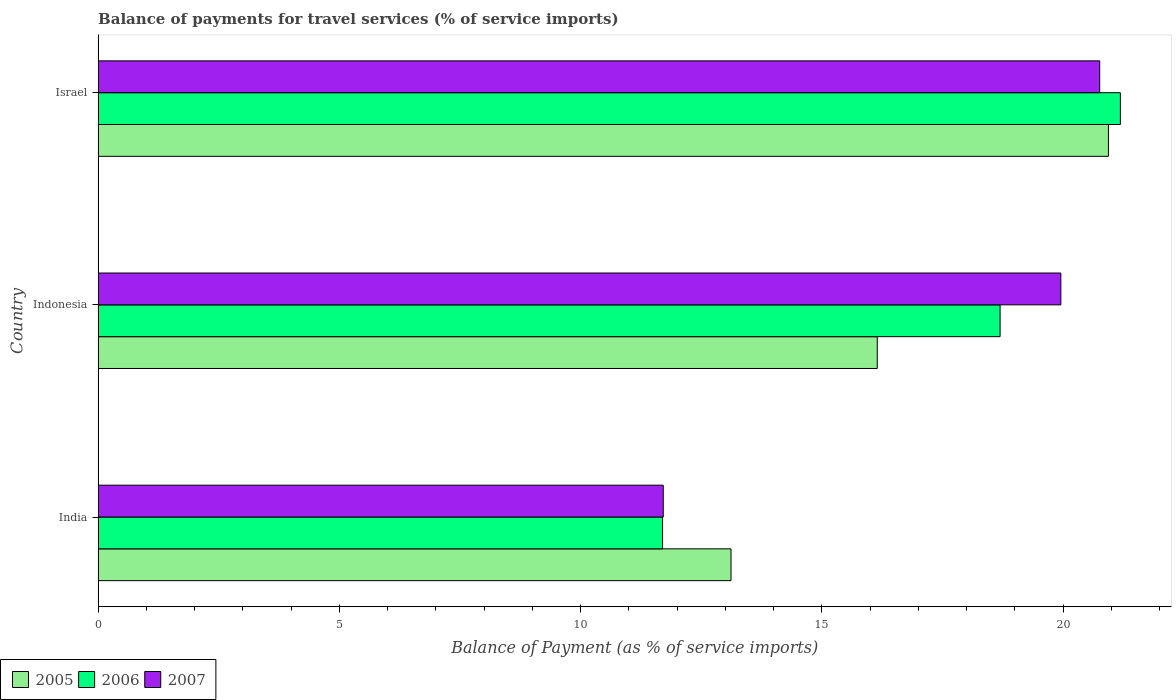How many different coloured bars are there?
Offer a terse response. 3. Are the number of bars per tick equal to the number of legend labels?
Offer a very short reply. Yes. How many bars are there on the 2nd tick from the bottom?
Give a very brief answer. 3. What is the balance of payments for travel services in 2006 in Israel?
Your answer should be compact. 21.19. Across all countries, what is the maximum balance of payments for travel services in 2006?
Your answer should be compact. 21.19. Across all countries, what is the minimum balance of payments for travel services in 2007?
Your answer should be compact. 11.71. What is the total balance of payments for travel services in 2006 in the graph?
Give a very brief answer. 51.58. What is the difference between the balance of payments for travel services in 2005 in India and that in Israel?
Your response must be concise. -7.82. What is the difference between the balance of payments for travel services in 2007 in Israel and the balance of payments for travel services in 2006 in Indonesia?
Offer a terse response. 2.06. What is the average balance of payments for travel services in 2006 per country?
Your answer should be compact. 17.19. What is the difference between the balance of payments for travel services in 2007 and balance of payments for travel services in 2005 in India?
Provide a succinct answer. -1.4. What is the ratio of the balance of payments for travel services in 2007 in India to that in Indonesia?
Ensure brevity in your answer.  0.59. Is the balance of payments for travel services in 2007 in India less than that in Indonesia?
Your response must be concise. Yes. What is the difference between the highest and the second highest balance of payments for travel services in 2006?
Give a very brief answer. 2.49. What is the difference between the highest and the lowest balance of payments for travel services in 2005?
Ensure brevity in your answer.  7.82. In how many countries, is the balance of payments for travel services in 2006 greater than the average balance of payments for travel services in 2006 taken over all countries?
Your answer should be very brief. 2. Is it the case that in every country, the sum of the balance of payments for travel services in 2007 and balance of payments for travel services in 2005 is greater than the balance of payments for travel services in 2006?
Your response must be concise. Yes. Are all the bars in the graph horizontal?
Give a very brief answer. Yes. How many legend labels are there?
Your response must be concise. 3. What is the title of the graph?
Provide a succinct answer. Balance of payments for travel services (% of service imports). Does "1998" appear as one of the legend labels in the graph?
Give a very brief answer. No. What is the label or title of the X-axis?
Your response must be concise. Balance of Payment (as % of service imports). What is the Balance of Payment (as % of service imports) in 2005 in India?
Give a very brief answer. 13.12. What is the Balance of Payment (as % of service imports) in 2006 in India?
Your answer should be compact. 11.7. What is the Balance of Payment (as % of service imports) in 2007 in India?
Your answer should be very brief. 11.71. What is the Balance of Payment (as % of service imports) of 2005 in Indonesia?
Provide a short and direct response. 16.15. What is the Balance of Payment (as % of service imports) in 2006 in Indonesia?
Keep it short and to the point. 18.69. What is the Balance of Payment (as % of service imports) in 2007 in Indonesia?
Provide a short and direct response. 19.95. What is the Balance of Payment (as % of service imports) of 2005 in Israel?
Provide a short and direct response. 20.94. What is the Balance of Payment (as % of service imports) in 2006 in Israel?
Make the answer very short. 21.19. What is the Balance of Payment (as % of service imports) in 2007 in Israel?
Your response must be concise. 20.76. Across all countries, what is the maximum Balance of Payment (as % of service imports) in 2005?
Offer a terse response. 20.94. Across all countries, what is the maximum Balance of Payment (as % of service imports) of 2006?
Offer a very short reply. 21.19. Across all countries, what is the maximum Balance of Payment (as % of service imports) in 2007?
Make the answer very short. 20.76. Across all countries, what is the minimum Balance of Payment (as % of service imports) of 2005?
Keep it short and to the point. 13.12. Across all countries, what is the minimum Balance of Payment (as % of service imports) in 2006?
Provide a succinct answer. 11.7. Across all countries, what is the minimum Balance of Payment (as % of service imports) of 2007?
Keep it short and to the point. 11.71. What is the total Balance of Payment (as % of service imports) of 2005 in the graph?
Keep it short and to the point. 50.2. What is the total Balance of Payment (as % of service imports) of 2006 in the graph?
Your answer should be very brief. 51.58. What is the total Balance of Payment (as % of service imports) of 2007 in the graph?
Your answer should be very brief. 52.42. What is the difference between the Balance of Payment (as % of service imports) in 2005 in India and that in Indonesia?
Keep it short and to the point. -3.03. What is the difference between the Balance of Payment (as % of service imports) in 2006 in India and that in Indonesia?
Offer a terse response. -7. What is the difference between the Balance of Payment (as % of service imports) in 2007 in India and that in Indonesia?
Ensure brevity in your answer.  -8.24. What is the difference between the Balance of Payment (as % of service imports) in 2005 in India and that in Israel?
Offer a terse response. -7.82. What is the difference between the Balance of Payment (as % of service imports) in 2006 in India and that in Israel?
Make the answer very short. -9.49. What is the difference between the Balance of Payment (as % of service imports) in 2007 in India and that in Israel?
Ensure brevity in your answer.  -9.05. What is the difference between the Balance of Payment (as % of service imports) of 2005 in Indonesia and that in Israel?
Offer a very short reply. -4.79. What is the difference between the Balance of Payment (as % of service imports) of 2006 in Indonesia and that in Israel?
Provide a short and direct response. -2.49. What is the difference between the Balance of Payment (as % of service imports) of 2007 in Indonesia and that in Israel?
Provide a short and direct response. -0.81. What is the difference between the Balance of Payment (as % of service imports) of 2005 in India and the Balance of Payment (as % of service imports) of 2006 in Indonesia?
Offer a very short reply. -5.58. What is the difference between the Balance of Payment (as % of service imports) in 2005 in India and the Balance of Payment (as % of service imports) in 2007 in Indonesia?
Your answer should be very brief. -6.84. What is the difference between the Balance of Payment (as % of service imports) in 2006 in India and the Balance of Payment (as % of service imports) in 2007 in Indonesia?
Your answer should be very brief. -8.25. What is the difference between the Balance of Payment (as % of service imports) in 2005 in India and the Balance of Payment (as % of service imports) in 2006 in Israel?
Make the answer very short. -8.07. What is the difference between the Balance of Payment (as % of service imports) of 2005 in India and the Balance of Payment (as % of service imports) of 2007 in Israel?
Your response must be concise. -7.64. What is the difference between the Balance of Payment (as % of service imports) of 2006 in India and the Balance of Payment (as % of service imports) of 2007 in Israel?
Offer a terse response. -9.06. What is the difference between the Balance of Payment (as % of service imports) in 2005 in Indonesia and the Balance of Payment (as % of service imports) in 2006 in Israel?
Your response must be concise. -5.04. What is the difference between the Balance of Payment (as % of service imports) of 2005 in Indonesia and the Balance of Payment (as % of service imports) of 2007 in Israel?
Keep it short and to the point. -4.61. What is the difference between the Balance of Payment (as % of service imports) of 2006 in Indonesia and the Balance of Payment (as % of service imports) of 2007 in Israel?
Your answer should be very brief. -2.06. What is the average Balance of Payment (as % of service imports) in 2005 per country?
Offer a very short reply. 16.73. What is the average Balance of Payment (as % of service imports) of 2006 per country?
Offer a terse response. 17.19. What is the average Balance of Payment (as % of service imports) of 2007 per country?
Your answer should be compact. 17.47. What is the difference between the Balance of Payment (as % of service imports) of 2005 and Balance of Payment (as % of service imports) of 2006 in India?
Offer a very short reply. 1.42. What is the difference between the Balance of Payment (as % of service imports) in 2005 and Balance of Payment (as % of service imports) in 2007 in India?
Keep it short and to the point. 1.4. What is the difference between the Balance of Payment (as % of service imports) of 2006 and Balance of Payment (as % of service imports) of 2007 in India?
Keep it short and to the point. -0.01. What is the difference between the Balance of Payment (as % of service imports) of 2005 and Balance of Payment (as % of service imports) of 2006 in Indonesia?
Provide a short and direct response. -2.55. What is the difference between the Balance of Payment (as % of service imports) in 2005 and Balance of Payment (as % of service imports) in 2007 in Indonesia?
Provide a short and direct response. -3.8. What is the difference between the Balance of Payment (as % of service imports) in 2006 and Balance of Payment (as % of service imports) in 2007 in Indonesia?
Ensure brevity in your answer.  -1.26. What is the difference between the Balance of Payment (as % of service imports) in 2005 and Balance of Payment (as % of service imports) in 2006 in Israel?
Give a very brief answer. -0.25. What is the difference between the Balance of Payment (as % of service imports) of 2005 and Balance of Payment (as % of service imports) of 2007 in Israel?
Give a very brief answer. 0.18. What is the difference between the Balance of Payment (as % of service imports) of 2006 and Balance of Payment (as % of service imports) of 2007 in Israel?
Your answer should be compact. 0.43. What is the ratio of the Balance of Payment (as % of service imports) in 2005 in India to that in Indonesia?
Your response must be concise. 0.81. What is the ratio of the Balance of Payment (as % of service imports) of 2006 in India to that in Indonesia?
Offer a very short reply. 0.63. What is the ratio of the Balance of Payment (as % of service imports) in 2007 in India to that in Indonesia?
Your answer should be compact. 0.59. What is the ratio of the Balance of Payment (as % of service imports) of 2005 in India to that in Israel?
Your response must be concise. 0.63. What is the ratio of the Balance of Payment (as % of service imports) of 2006 in India to that in Israel?
Offer a terse response. 0.55. What is the ratio of the Balance of Payment (as % of service imports) in 2007 in India to that in Israel?
Provide a succinct answer. 0.56. What is the ratio of the Balance of Payment (as % of service imports) in 2005 in Indonesia to that in Israel?
Keep it short and to the point. 0.77. What is the ratio of the Balance of Payment (as % of service imports) in 2006 in Indonesia to that in Israel?
Make the answer very short. 0.88. What is the ratio of the Balance of Payment (as % of service imports) in 2007 in Indonesia to that in Israel?
Keep it short and to the point. 0.96. What is the difference between the highest and the second highest Balance of Payment (as % of service imports) of 2005?
Offer a terse response. 4.79. What is the difference between the highest and the second highest Balance of Payment (as % of service imports) in 2006?
Offer a terse response. 2.49. What is the difference between the highest and the second highest Balance of Payment (as % of service imports) in 2007?
Offer a terse response. 0.81. What is the difference between the highest and the lowest Balance of Payment (as % of service imports) in 2005?
Provide a short and direct response. 7.82. What is the difference between the highest and the lowest Balance of Payment (as % of service imports) in 2006?
Offer a very short reply. 9.49. What is the difference between the highest and the lowest Balance of Payment (as % of service imports) of 2007?
Offer a very short reply. 9.05. 